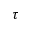<formula> <loc_0><loc_0><loc_500><loc_500>\tau</formula> 